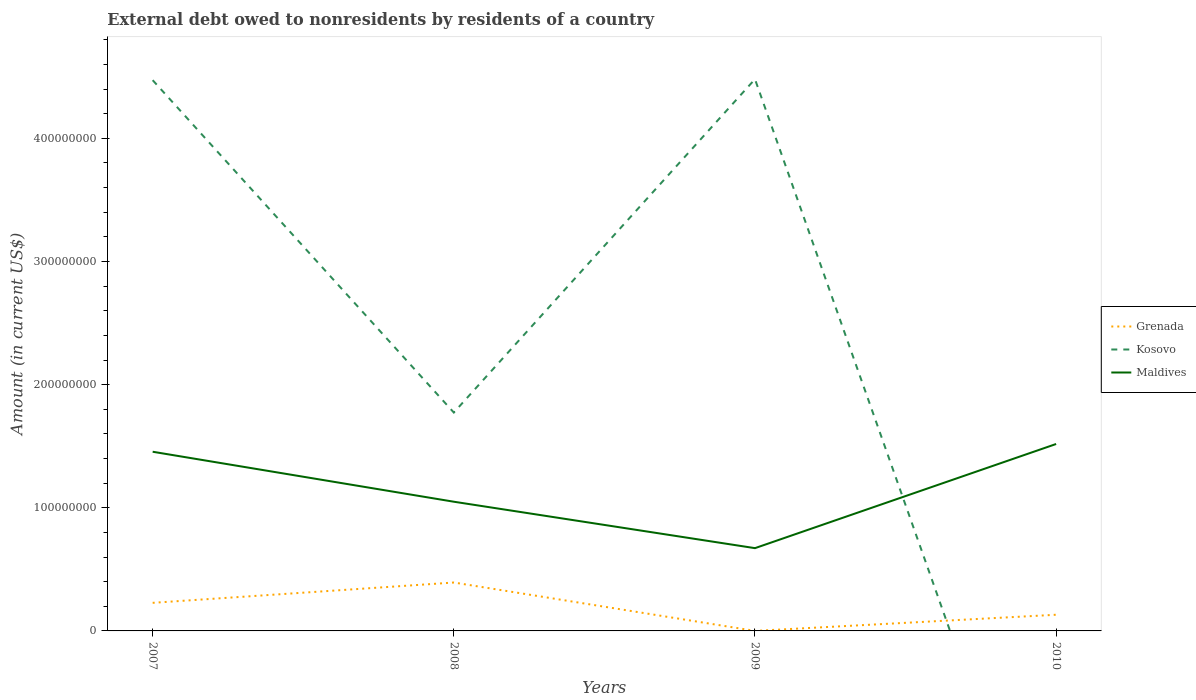How many different coloured lines are there?
Your answer should be very brief. 3. Does the line corresponding to Grenada intersect with the line corresponding to Kosovo?
Ensure brevity in your answer.  Yes. Is the number of lines equal to the number of legend labels?
Your answer should be very brief. No. Across all years, what is the maximum external debt owed by residents in Grenada?
Offer a very short reply. 2.30e+04. What is the total external debt owed by residents in Maldives in the graph?
Provide a short and direct response. -4.69e+07. What is the difference between the highest and the second highest external debt owed by residents in Kosovo?
Your response must be concise. 4.48e+08. What is the difference between the highest and the lowest external debt owed by residents in Maldives?
Provide a short and direct response. 2. Are the values on the major ticks of Y-axis written in scientific E-notation?
Keep it short and to the point. No. Does the graph contain grids?
Ensure brevity in your answer.  No. How many legend labels are there?
Keep it short and to the point. 3. What is the title of the graph?
Provide a succinct answer. External debt owed to nonresidents by residents of a country. Does "Australia" appear as one of the legend labels in the graph?
Your answer should be compact. No. What is the label or title of the X-axis?
Give a very brief answer. Years. What is the Amount (in current US$) of Grenada in 2007?
Ensure brevity in your answer.  2.28e+07. What is the Amount (in current US$) in Kosovo in 2007?
Keep it short and to the point. 4.47e+08. What is the Amount (in current US$) of Maldives in 2007?
Keep it short and to the point. 1.46e+08. What is the Amount (in current US$) of Grenada in 2008?
Ensure brevity in your answer.  3.93e+07. What is the Amount (in current US$) in Kosovo in 2008?
Your answer should be very brief. 1.77e+08. What is the Amount (in current US$) of Maldives in 2008?
Your answer should be compact. 1.05e+08. What is the Amount (in current US$) in Grenada in 2009?
Ensure brevity in your answer.  2.30e+04. What is the Amount (in current US$) of Kosovo in 2009?
Your response must be concise. 4.48e+08. What is the Amount (in current US$) of Maldives in 2009?
Provide a succinct answer. 6.72e+07. What is the Amount (in current US$) of Grenada in 2010?
Provide a short and direct response. 1.31e+07. What is the Amount (in current US$) in Kosovo in 2010?
Your answer should be compact. 0. What is the Amount (in current US$) of Maldives in 2010?
Keep it short and to the point. 1.52e+08. Across all years, what is the maximum Amount (in current US$) in Grenada?
Keep it short and to the point. 3.93e+07. Across all years, what is the maximum Amount (in current US$) of Kosovo?
Offer a very short reply. 4.48e+08. Across all years, what is the maximum Amount (in current US$) of Maldives?
Provide a short and direct response. 1.52e+08. Across all years, what is the minimum Amount (in current US$) in Grenada?
Your response must be concise. 2.30e+04. Across all years, what is the minimum Amount (in current US$) of Maldives?
Ensure brevity in your answer.  6.72e+07. What is the total Amount (in current US$) in Grenada in the graph?
Give a very brief answer. 7.53e+07. What is the total Amount (in current US$) in Kosovo in the graph?
Provide a short and direct response. 1.07e+09. What is the total Amount (in current US$) in Maldives in the graph?
Make the answer very short. 4.69e+08. What is the difference between the Amount (in current US$) of Grenada in 2007 and that in 2008?
Make the answer very short. -1.65e+07. What is the difference between the Amount (in current US$) in Kosovo in 2007 and that in 2008?
Make the answer very short. 2.70e+08. What is the difference between the Amount (in current US$) in Maldives in 2007 and that in 2008?
Your answer should be compact. 4.06e+07. What is the difference between the Amount (in current US$) in Grenada in 2007 and that in 2009?
Your answer should be very brief. 2.28e+07. What is the difference between the Amount (in current US$) of Kosovo in 2007 and that in 2009?
Your answer should be very brief. -8.17e+05. What is the difference between the Amount (in current US$) of Maldives in 2007 and that in 2009?
Provide a succinct answer. 7.83e+07. What is the difference between the Amount (in current US$) of Grenada in 2007 and that in 2010?
Keep it short and to the point. 9.68e+06. What is the difference between the Amount (in current US$) of Maldives in 2007 and that in 2010?
Give a very brief answer. -6.29e+06. What is the difference between the Amount (in current US$) of Grenada in 2008 and that in 2009?
Offer a very short reply. 3.93e+07. What is the difference between the Amount (in current US$) in Kosovo in 2008 and that in 2009?
Your response must be concise. -2.71e+08. What is the difference between the Amount (in current US$) in Maldives in 2008 and that in 2009?
Offer a terse response. 3.77e+07. What is the difference between the Amount (in current US$) in Grenada in 2008 and that in 2010?
Provide a succinct answer. 2.62e+07. What is the difference between the Amount (in current US$) in Maldives in 2008 and that in 2010?
Your response must be concise. -4.69e+07. What is the difference between the Amount (in current US$) in Grenada in 2009 and that in 2010?
Ensure brevity in your answer.  -1.31e+07. What is the difference between the Amount (in current US$) in Maldives in 2009 and that in 2010?
Provide a short and direct response. -8.46e+07. What is the difference between the Amount (in current US$) of Grenada in 2007 and the Amount (in current US$) of Kosovo in 2008?
Ensure brevity in your answer.  -1.55e+08. What is the difference between the Amount (in current US$) in Grenada in 2007 and the Amount (in current US$) in Maldives in 2008?
Provide a short and direct response. -8.21e+07. What is the difference between the Amount (in current US$) in Kosovo in 2007 and the Amount (in current US$) in Maldives in 2008?
Make the answer very short. 3.42e+08. What is the difference between the Amount (in current US$) of Grenada in 2007 and the Amount (in current US$) of Kosovo in 2009?
Keep it short and to the point. -4.25e+08. What is the difference between the Amount (in current US$) of Grenada in 2007 and the Amount (in current US$) of Maldives in 2009?
Ensure brevity in your answer.  -4.44e+07. What is the difference between the Amount (in current US$) in Kosovo in 2007 and the Amount (in current US$) in Maldives in 2009?
Provide a succinct answer. 3.80e+08. What is the difference between the Amount (in current US$) of Grenada in 2007 and the Amount (in current US$) of Maldives in 2010?
Provide a succinct answer. -1.29e+08. What is the difference between the Amount (in current US$) in Kosovo in 2007 and the Amount (in current US$) in Maldives in 2010?
Offer a terse response. 2.95e+08. What is the difference between the Amount (in current US$) in Grenada in 2008 and the Amount (in current US$) in Kosovo in 2009?
Offer a very short reply. -4.09e+08. What is the difference between the Amount (in current US$) of Grenada in 2008 and the Amount (in current US$) of Maldives in 2009?
Give a very brief answer. -2.79e+07. What is the difference between the Amount (in current US$) in Kosovo in 2008 and the Amount (in current US$) in Maldives in 2009?
Offer a terse response. 1.10e+08. What is the difference between the Amount (in current US$) of Grenada in 2008 and the Amount (in current US$) of Maldives in 2010?
Offer a very short reply. -1.12e+08. What is the difference between the Amount (in current US$) in Kosovo in 2008 and the Amount (in current US$) in Maldives in 2010?
Keep it short and to the point. 2.56e+07. What is the difference between the Amount (in current US$) in Grenada in 2009 and the Amount (in current US$) in Maldives in 2010?
Offer a very short reply. -1.52e+08. What is the difference between the Amount (in current US$) in Kosovo in 2009 and the Amount (in current US$) in Maldives in 2010?
Offer a very short reply. 2.96e+08. What is the average Amount (in current US$) in Grenada per year?
Your answer should be compact. 1.88e+07. What is the average Amount (in current US$) in Kosovo per year?
Keep it short and to the point. 2.68e+08. What is the average Amount (in current US$) of Maldives per year?
Offer a very short reply. 1.17e+08. In the year 2007, what is the difference between the Amount (in current US$) in Grenada and Amount (in current US$) in Kosovo?
Your response must be concise. -4.24e+08. In the year 2007, what is the difference between the Amount (in current US$) in Grenada and Amount (in current US$) in Maldives?
Offer a very short reply. -1.23e+08. In the year 2007, what is the difference between the Amount (in current US$) of Kosovo and Amount (in current US$) of Maldives?
Ensure brevity in your answer.  3.02e+08. In the year 2008, what is the difference between the Amount (in current US$) of Grenada and Amount (in current US$) of Kosovo?
Provide a short and direct response. -1.38e+08. In the year 2008, what is the difference between the Amount (in current US$) in Grenada and Amount (in current US$) in Maldives?
Keep it short and to the point. -6.56e+07. In the year 2008, what is the difference between the Amount (in current US$) of Kosovo and Amount (in current US$) of Maldives?
Keep it short and to the point. 7.24e+07. In the year 2009, what is the difference between the Amount (in current US$) of Grenada and Amount (in current US$) of Kosovo?
Your answer should be compact. -4.48e+08. In the year 2009, what is the difference between the Amount (in current US$) of Grenada and Amount (in current US$) of Maldives?
Make the answer very short. -6.72e+07. In the year 2009, what is the difference between the Amount (in current US$) in Kosovo and Amount (in current US$) in Maldives?
Ensure brevity in your answer.  3.81e+08. In the year 2010, what is the difference between the Amount (in current US$) in Grenada and Amount (in current US$) in Maldives?
Offer a terse response. -1.39e+08. What is the ratio of the Amount (in current US$) of Grenada in 2007 to that in 2008?
Offer a very short reply. 0.58. What is the ratio of the Amount (in current US$) in Kosovo in 2007 to that in 2008?
Provide a short and direct response. 2.52. What is the ratio of the Amount (in current US$) of Maldives in 2007 to that in 2008?
Your answer should be very brief. 1.39. What is the ratio of the Amount (in current US$) in Grenada in 2007 to that in 2009?
Your answer should be very brief. 991.83. What is the ratio of the Amount (in current US$) of Kosovo in 2007 to that in 2009?
Your response must be concise. 1. What is the ratio of the Amount (in current US$) in Maldives in 2007 to that in 2009?
Your response must be concise. 2.16. What is the ratio of the Amount (in current US$) in Grenada in 2007 to that in 2010?
Your answer should be compact. 1.74. What is the ratio of the Amount (in current US$) in Maldives in 2007 to that in 2010?
Offer a terse response. 0.96. What is the ratio of the Amount (in current US$) of Grenada in 2008 to that in 2009?
Your answer should be compact. 1708.83. What is the ratio of the Amount (in current US$) in Kosovo in 2008 to that in 2009?
Your answer should be very brief. 0.4. What is the ratio of the Amount (in current US$) in Maldives in 2008 to that in 2009?
Your answer should be compact. 1.56. What is the ratio of the Amount (in current US$) in Grenada in 2008 to that in 2010?
Your answer should be very brief. 2.99. What is the ratio of the Amount (in current US$) in Maldives in 2008 to that in 2010?
Keep it short and to the point. 0.69. What is the ratio of the Amount (in current US$) of Grenada in 2009 to that in 2010?
Provide a short and direct response. 0. What is the ratio of the Amount (in current US$) of Maldives in 2009 to that in 2010?
Offer a very short reply. 0.44. What is the difference between the highest and the second highest Amount (in current US$) of Grenada?
Give a very brief answer. 1.65e+07. What is the difference between the highest and the second highest Amount (in current US$) in Kosovo?
Your response must be concise. 8.17e+05. What is the difference between the highest and the second highest Amount (in current US$) in Maldives?
Provide a succinct answer. 6.29e+06. What is the difference between the highest and the lowest Amount (in current US$) in Grenada?
Make the answer very short. 3.93e+07. What is the difference between the highest and the lowest Amount (in current US$) in Kosovo?
Your response must be concise. 4.48e+08. What is the difference between the highest and the lowest Amount (in current US$) of Maldives?
Your answer should be very brief. 8.46e+07. 